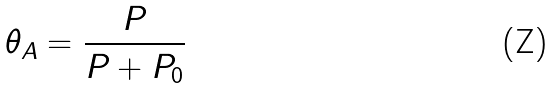Convert formula to latex. <formula><loc_0><loc_0><loc_500><loc_500>\theta _ { A } = \frac { P } { P + P _ { 0 } }</formula> 